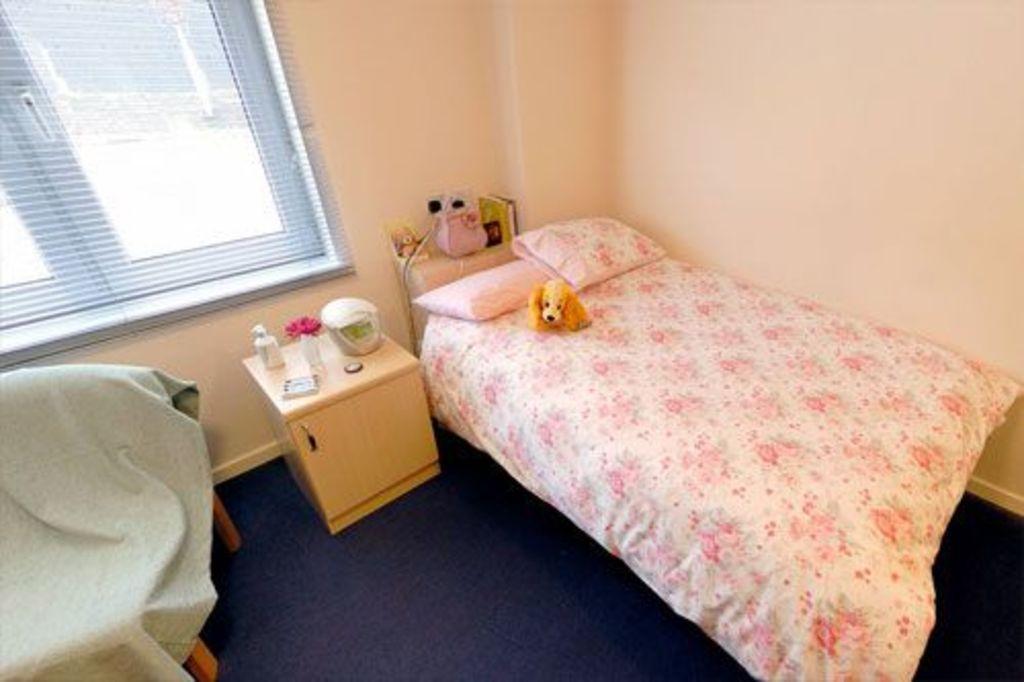Can you describe this image briefly? In this image, we can see a bed, we can see pillows on the bed, there is a table, we can see a chair and there is a blanket on the chair, we can see a window and there is a wall. 